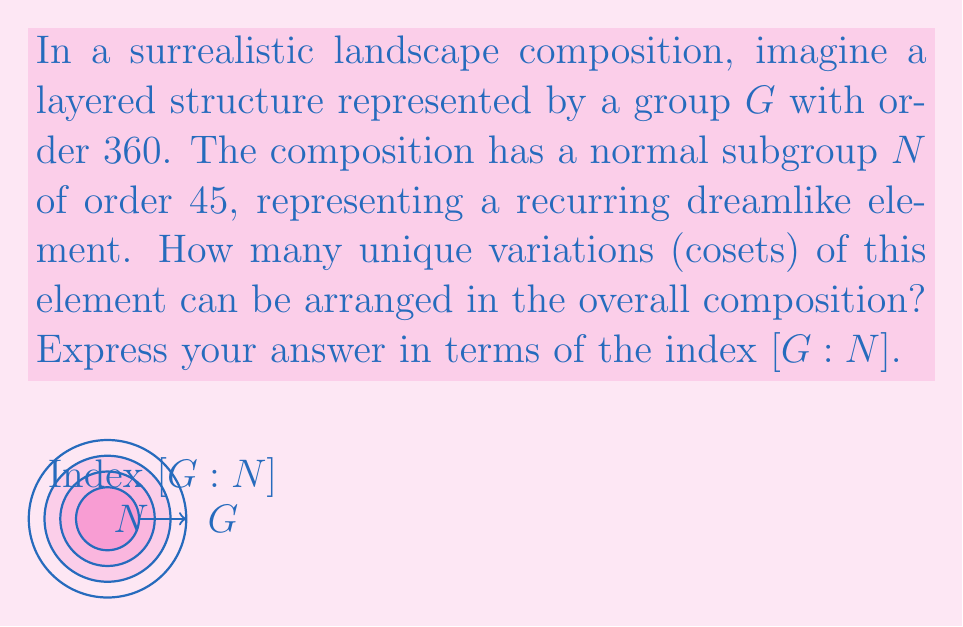Could you help me with this problem? To solve this problem, we need to understand the concept of index in group theory and how it relates to the order of the group and its subgroup. Let's break it down step-by-step:

1) The index of a subgroup $N$ in a group $G$ is denoted as $[G:N]$ and is defined as the number of distinct left (or right) cosets of $N$ in $G$.

2) There's a fundamental theorem in group theory that states:
   $$[G:N] = \frac{|G|}{|N|}$$
   where $|G|$ is the order of group $G$ and $|N|$ is the order of subgroup $N$.

3) In our case:
   $|G| = 360$ (the order of the entire group)
   $|N| = 45$ (the order of the normal subgroup)

4) Substituting these values into the formula:
   $$[G:N] = \frac{|G|}{|N|} = \frac{360}{45}$$

5) Simplifying:
   $$[G:N] = \frac{360}{45} = 8$$

Therefore, there are 8 unique variations (cosets) of the recurring dreamlike element that can be arranged in the overall composition.
Answer: $[G:N] = 8$ 